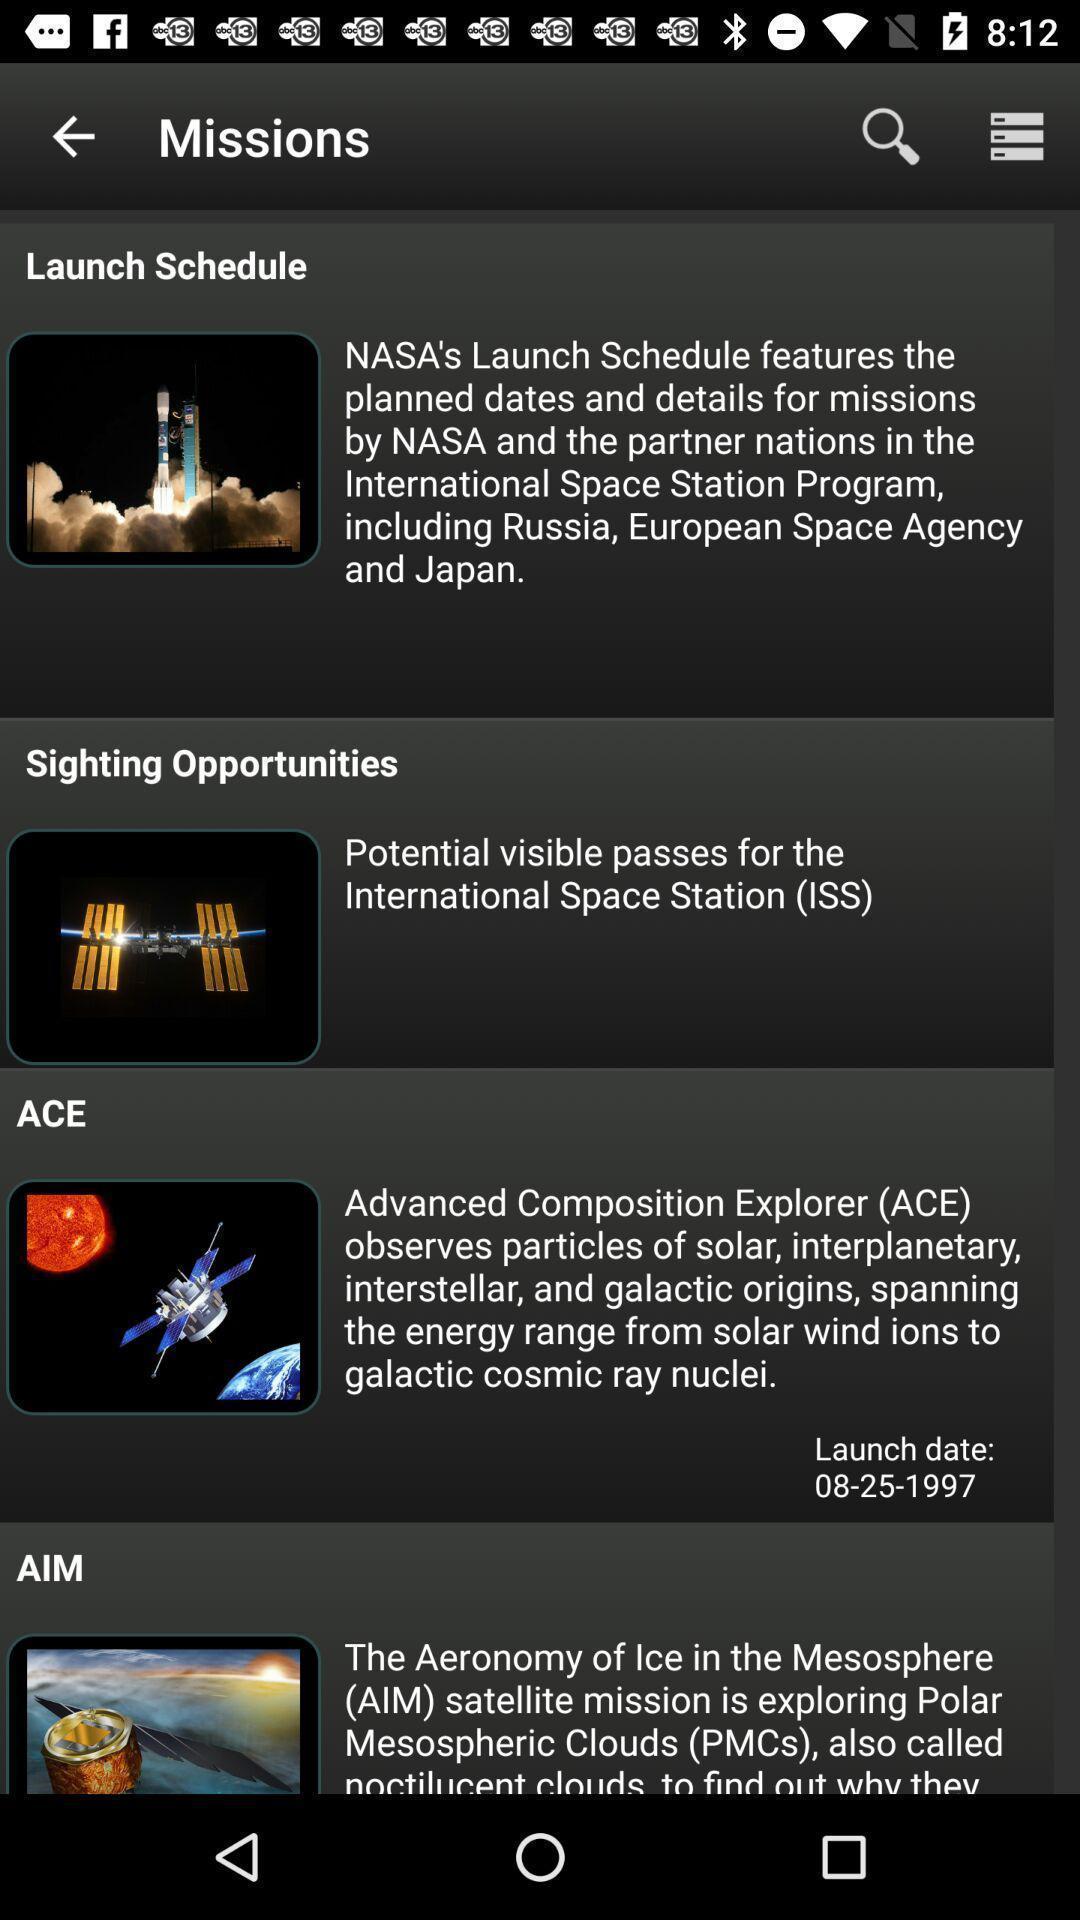What details can you identify in this image? Screen displaying multiple articles information with pictures. 